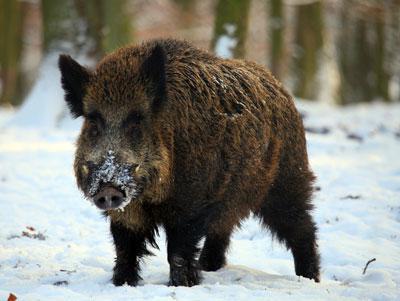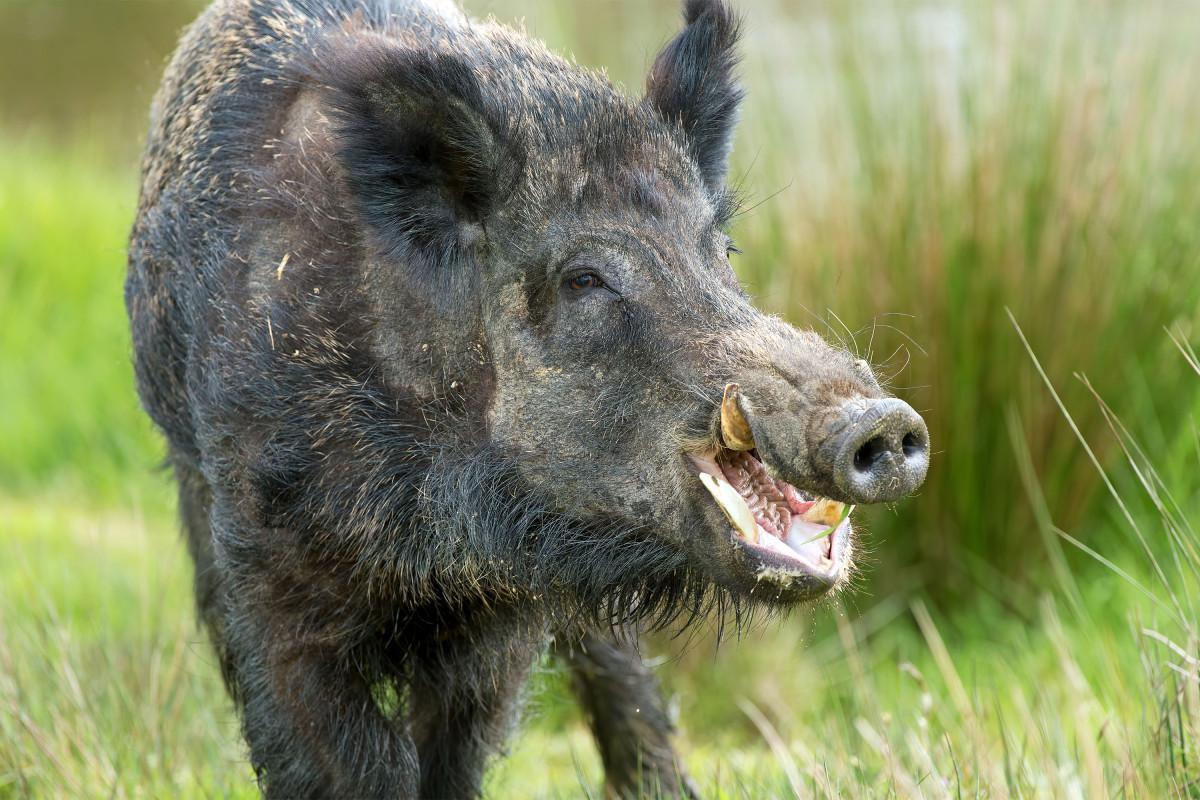The first image is the image on the left, the second image is the image on the right. For the images displayed, is the sentence "The animal in the image on the left has its body turned to the right." factually correct? Answer yes or no. No. 